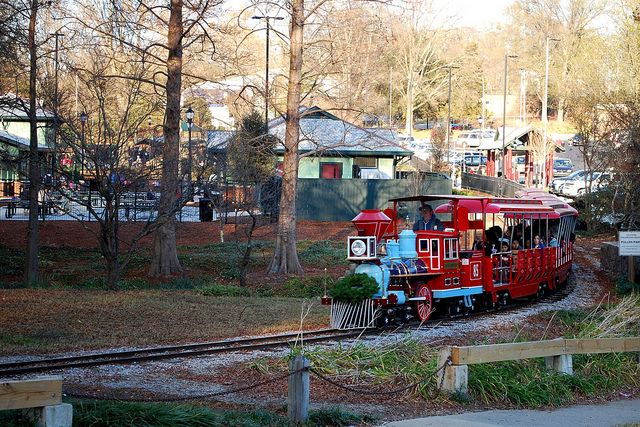Read all the text in this image. 15 